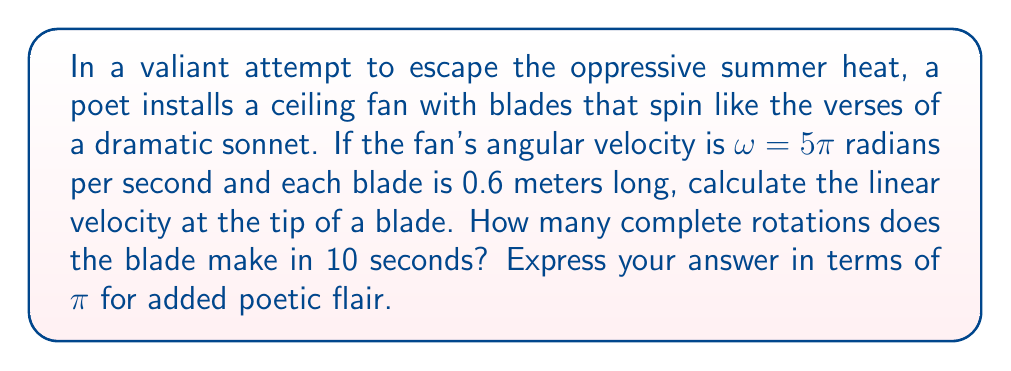Can you solve this math problem? Let's approach this problem step by step, with the grace of a well-crafted verse:

1) First, we'll calculate the linear velocity at the tip of the blade:
   The formula for linear velocity $v$ in terms of angular velocity $\omega$ and radius $r$ is:
   $$v = \omega r$$
   
   Here, $\omega = 5\pi$ rad/s and $r = 0.6$ m
   
   $$v = 5\pi \cdot 0.6 = 3\pi \text{ m/s}$$

2) Now, for the number of complete rotations in 10 seconds:
   We know that $\omega = 5\pi$ rad/s
   
   In one complete rotation, the blade covers $2\pi$ radians
   
   So, the number of rotations per second = $\frac{5\pi}{2\pi} = 2.5$
   
   In 10 seconds, the number of rotations = $2.5 \cdot 10 = 25$

Thus, in 10 seconds, the blade makes 25 complete rotations, spinning a cooling tale to combat the sweltering heat.
Answer: Linear velocity at blade tip: $3\pi$ m/s
Number of complete rotations in 10 seconds: 25 